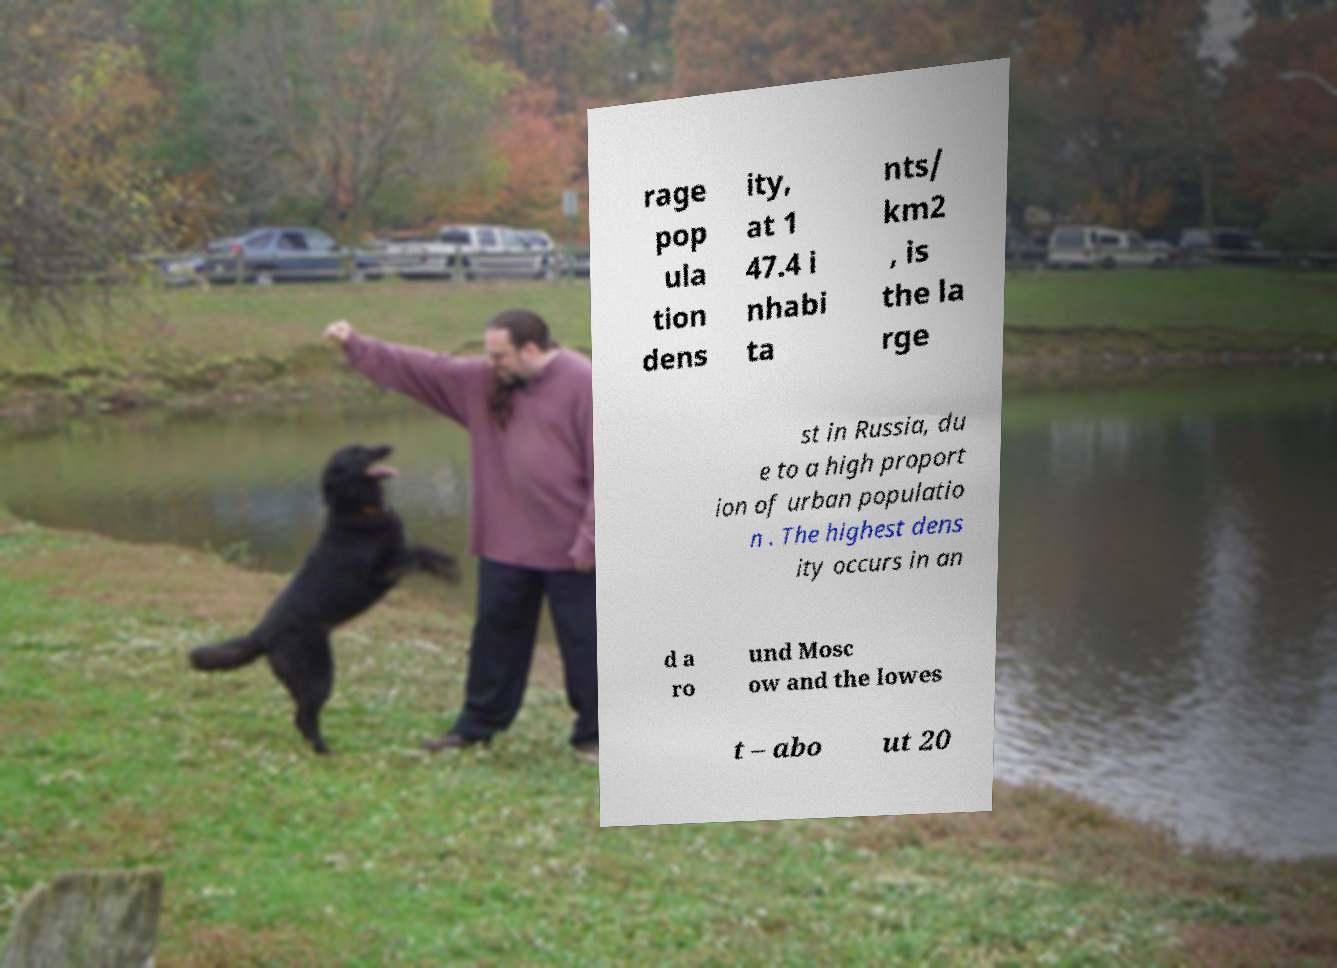For documentation purposes, I need the text within this image transcribed. Could you provide that? rage pop ula tion dens ity, at 1 47.4 i nhabi ta nts/ km2 , is the la rge st in Russia, du e to a high proport ion of urban populatio n . The highest dens ity occurs in an d a ro und Mosc ow and the lowes t – abo ut 20 